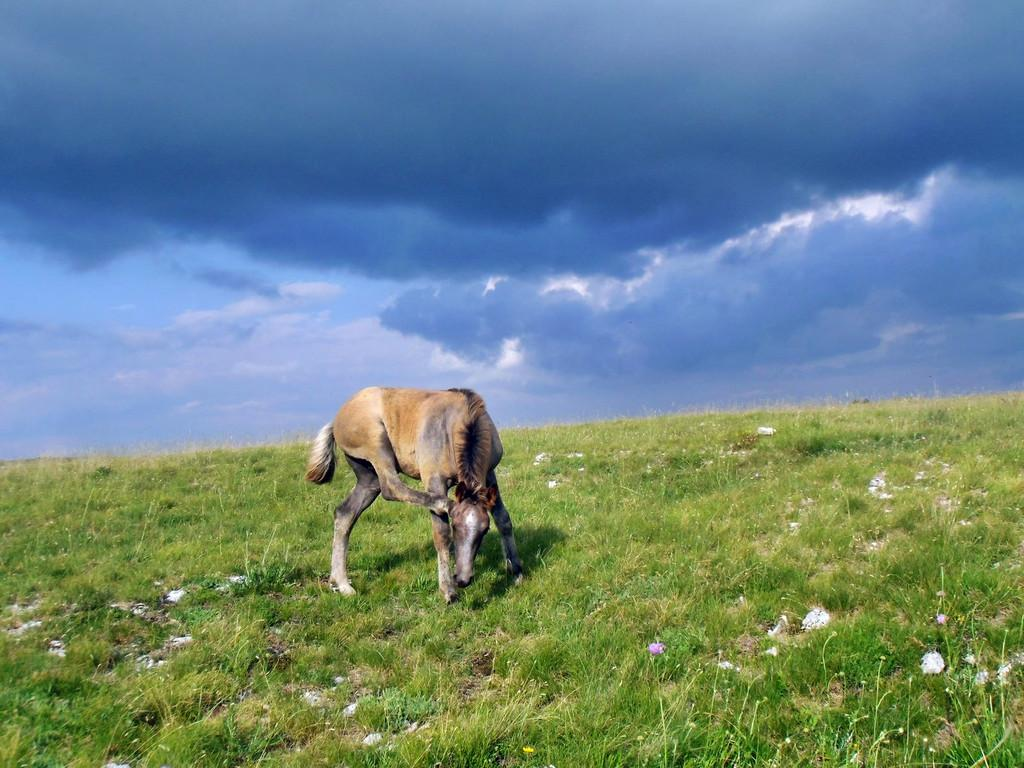What is the main subject in the middle of the image? There is an animal in the middle of the image. What type of vegetation is present at the bottom of the image? There is grass at the bottom of the image. What is the condition of the sky in the image? The sky is cloudy and visible at the top of the image. How many frogs are sitting on the arm of the doll in the image? There is no doll or frogs present in the image. 